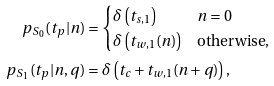<formula> <loc_0><loc_0><loc_500><loc_500>p _ { S _ { 0 } } ( t _ { p } | n ) & = \begin{cases} \delta \left ( t _ { s , 1 } \right ) & n = 0 \\ \delta \left ( t _ { w , 1 } ( n ) \right ) & \text {otherwise,} \end{cases} \\ p _ { S _ { 1 } } ( t _ { p } | n , q ) & = \delta \left ( t _ { c } + t _ { w , 1 } ( n + q ) \right ) ,</formula> 